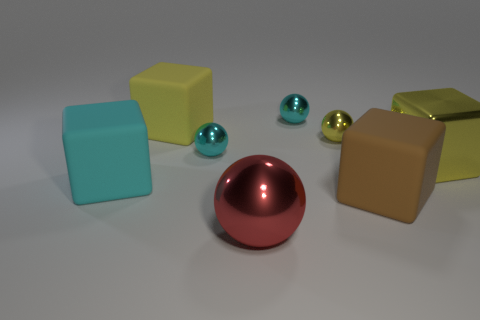How many large balls have the same color as the large shiny block?
Your answer should be very brief. 0. There is a yellow cube right of the cyan metal ball that is in front of the tiny metal sphere behind the large yellow matte cube; what is its material?
Provide a succinct answer. Metal. What color is the large rubber thing left of the cube that is behind the yellow metal ball?
Give a very brief answer. Cyan. What number of large things are yellow rubber cubes or metal objects?
Offer a terse response. 3. How many cyan objects are the same material as the brown object?
Make the answer very short. 1. What size is the object in front of the big brown rubber thing?
Offer a terse response. Large. What is the shape of the big shiny thing that is to the left of the big object right of the large brown object?
Offer a very short reply. Sphere. There is a yellow metallic object in front of the cyan metal ball left of the red metal sphere; what number of shiny balls are in front of it?
Your answer should be very brief. 1. Is the number of big yellow things in front of the large metallic cube less than the number of tiny cyan spheres?
Give a very brief answer. Yes. Is there any other thing that is the same shape as the big red thing?
Give a very brief answer. Yes. 